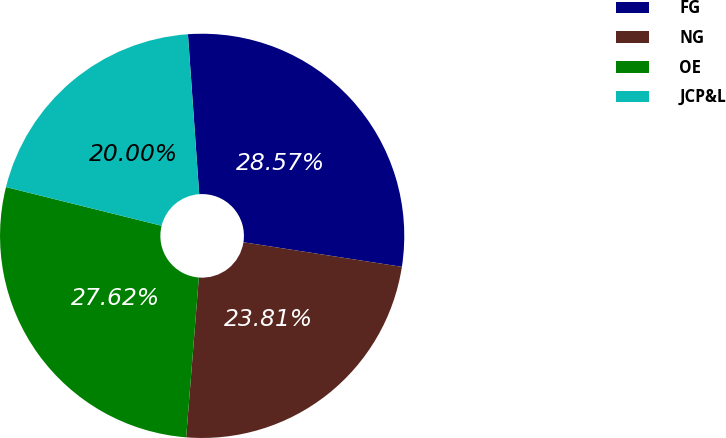Convert chart. <chart><loc_0><loc_0><loc_500><loc_500><pie_chart><fcel>FG<fcel>NG<fcel>OE<fcel>JCP&L<nl><fcel>28.57%<fcel>23.81%<fcel>27.62%<fcel>20.0%<nl></chart> 